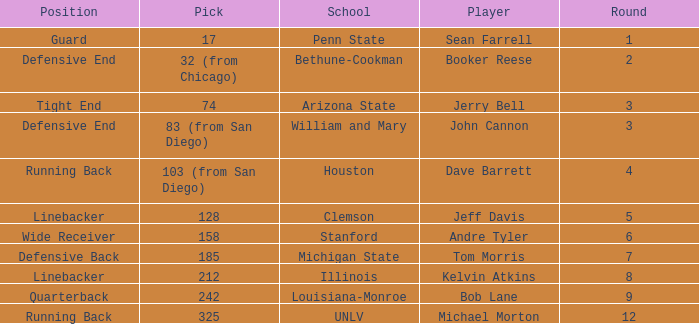In which round is pick number 242? 1.0. 